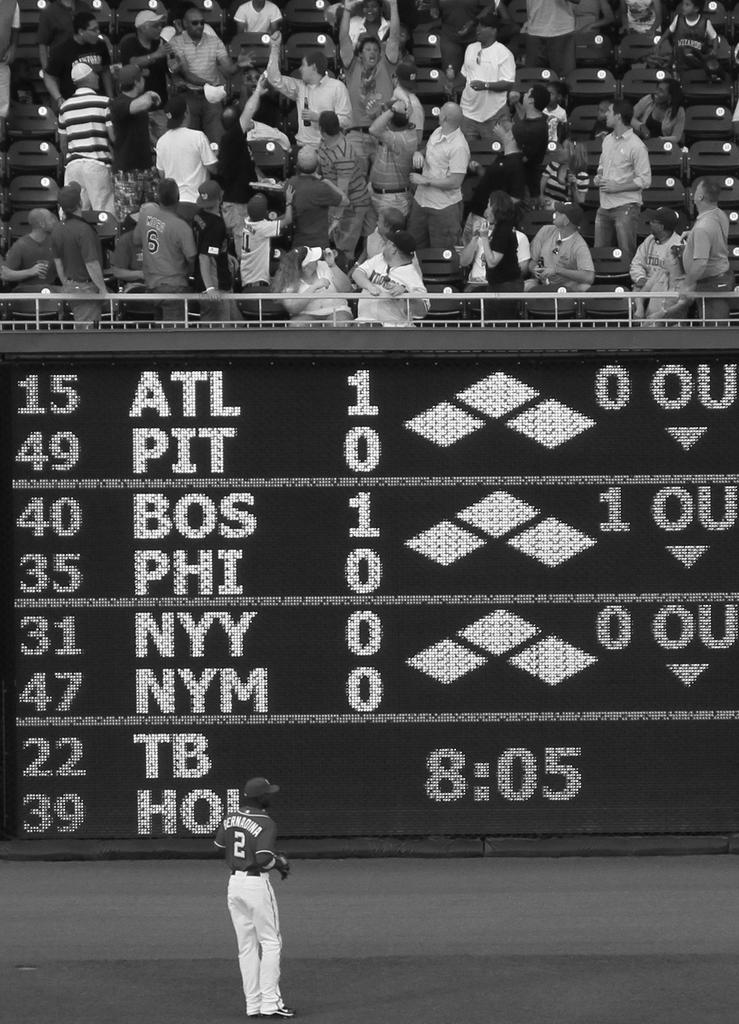<image>
Describe the image concisely. A scoreboard lists ATL first on the list of teams. 